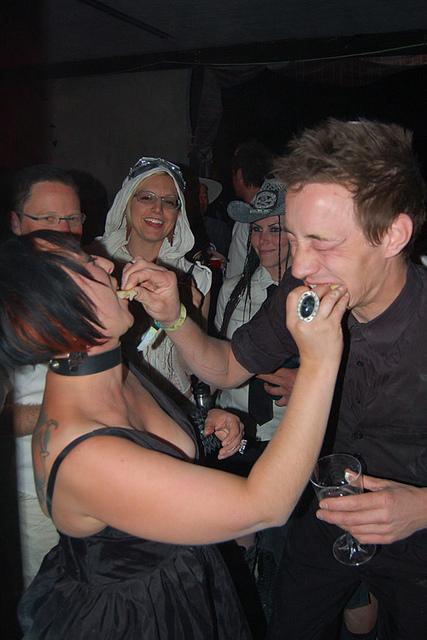How long is his tie?
Keep it brief. 6 inches. What shape is the woman's ring?
Short answer required. Oval. Could this be at a wine tasting?
Give a very brief answer. No. What color is the woman's dress?
Quick response, please. Black. Is the man biting the woman's hand?
Short answer required. No. What are the children playing?
Write a very short answer. Eating. 